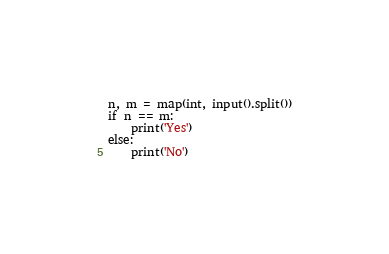<code> <loc_0><loc_0><loc_500><loc_500><_Python_>n, m = map(int, input().split())
if n == m:
    print('Yes')
else:
    print('No')</code> 